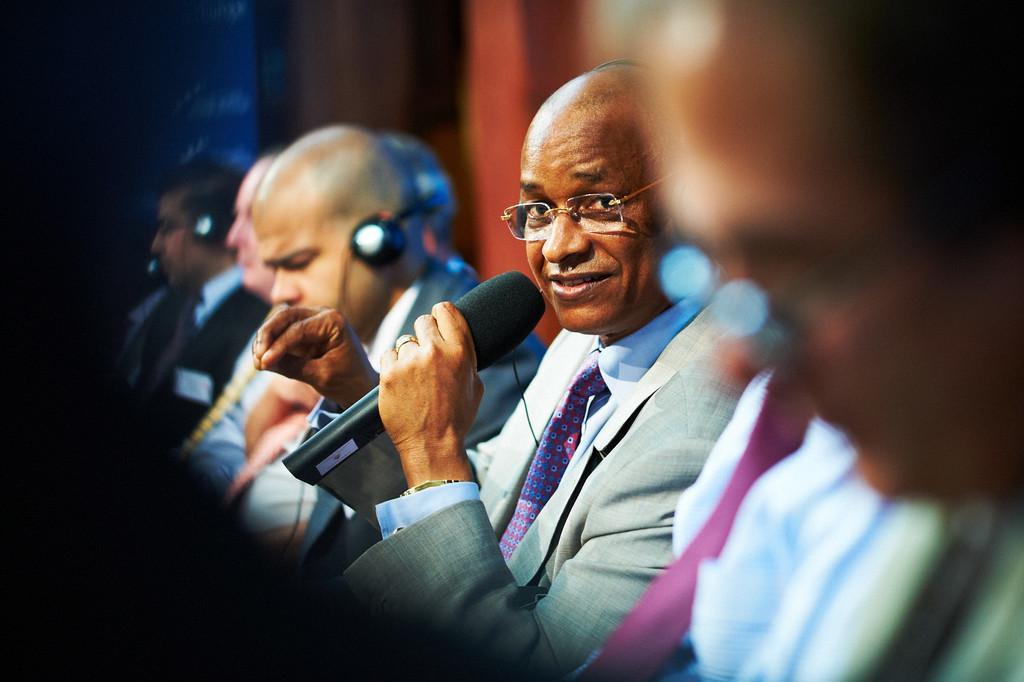Describe this image in one or two sentences. Here we see a group of people seated and we see a man holding a microphone and speaking. 